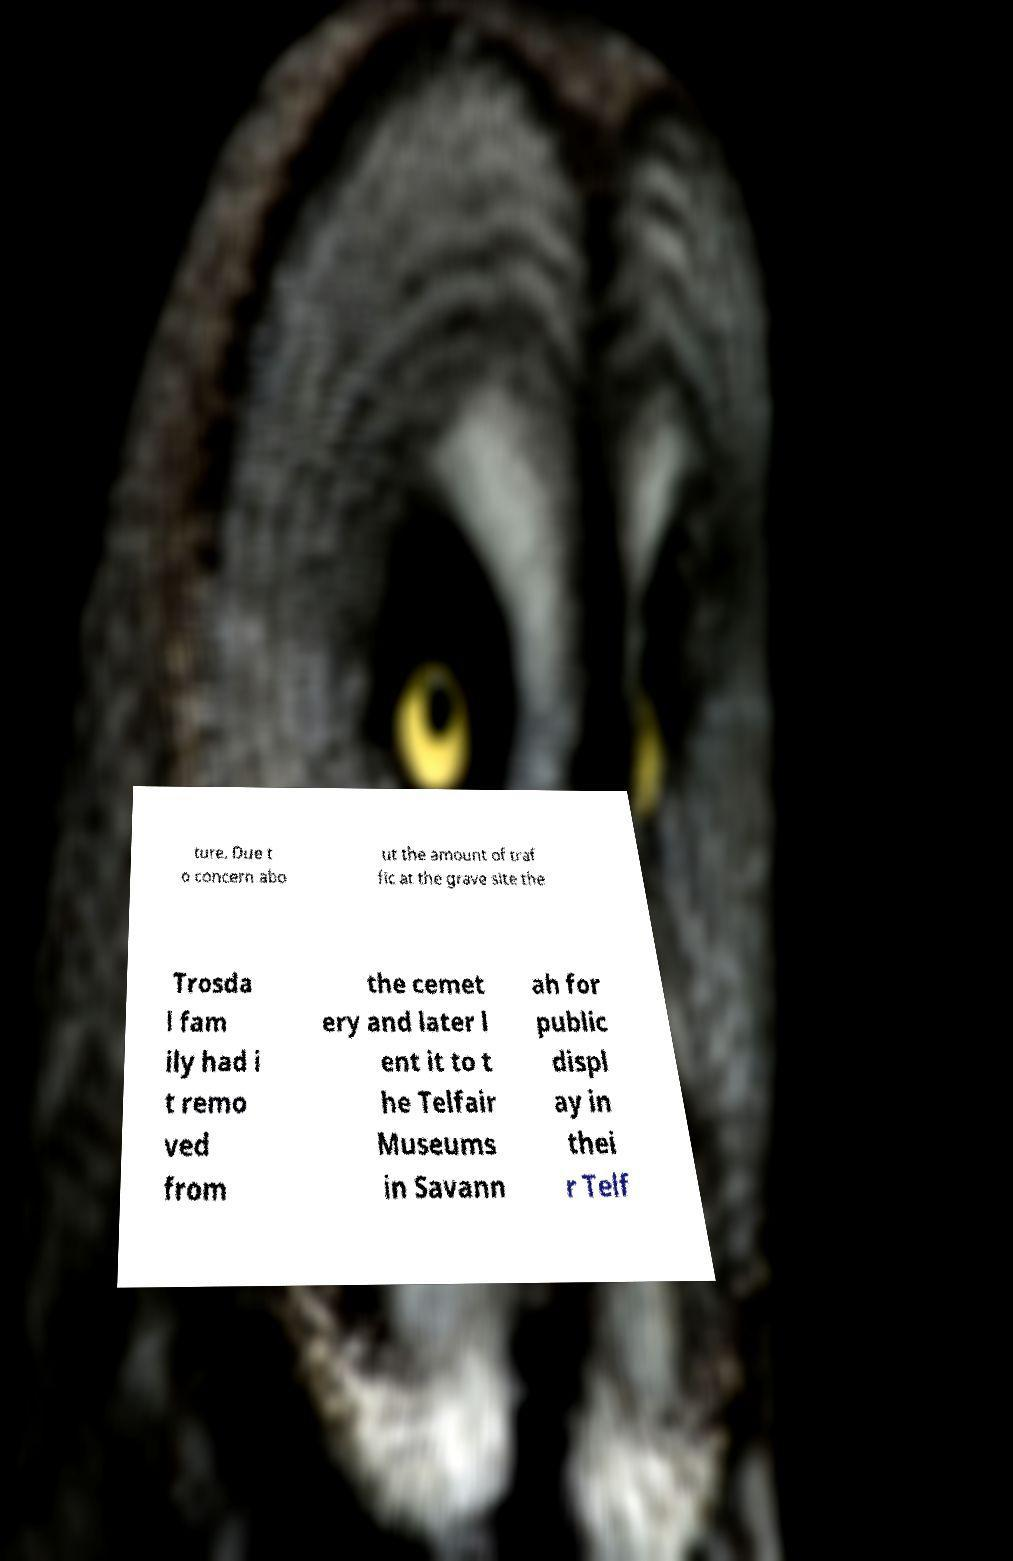Please identify and transcribe the text found in this image. ture. Due t o concern abo ut the amount of traf fic at the grave site the Trosda l fam ily had i t remo ved from the cemet ery and later l ent it to t he Telfair Museums in Savann ah for public displ ay in thei r Telf 